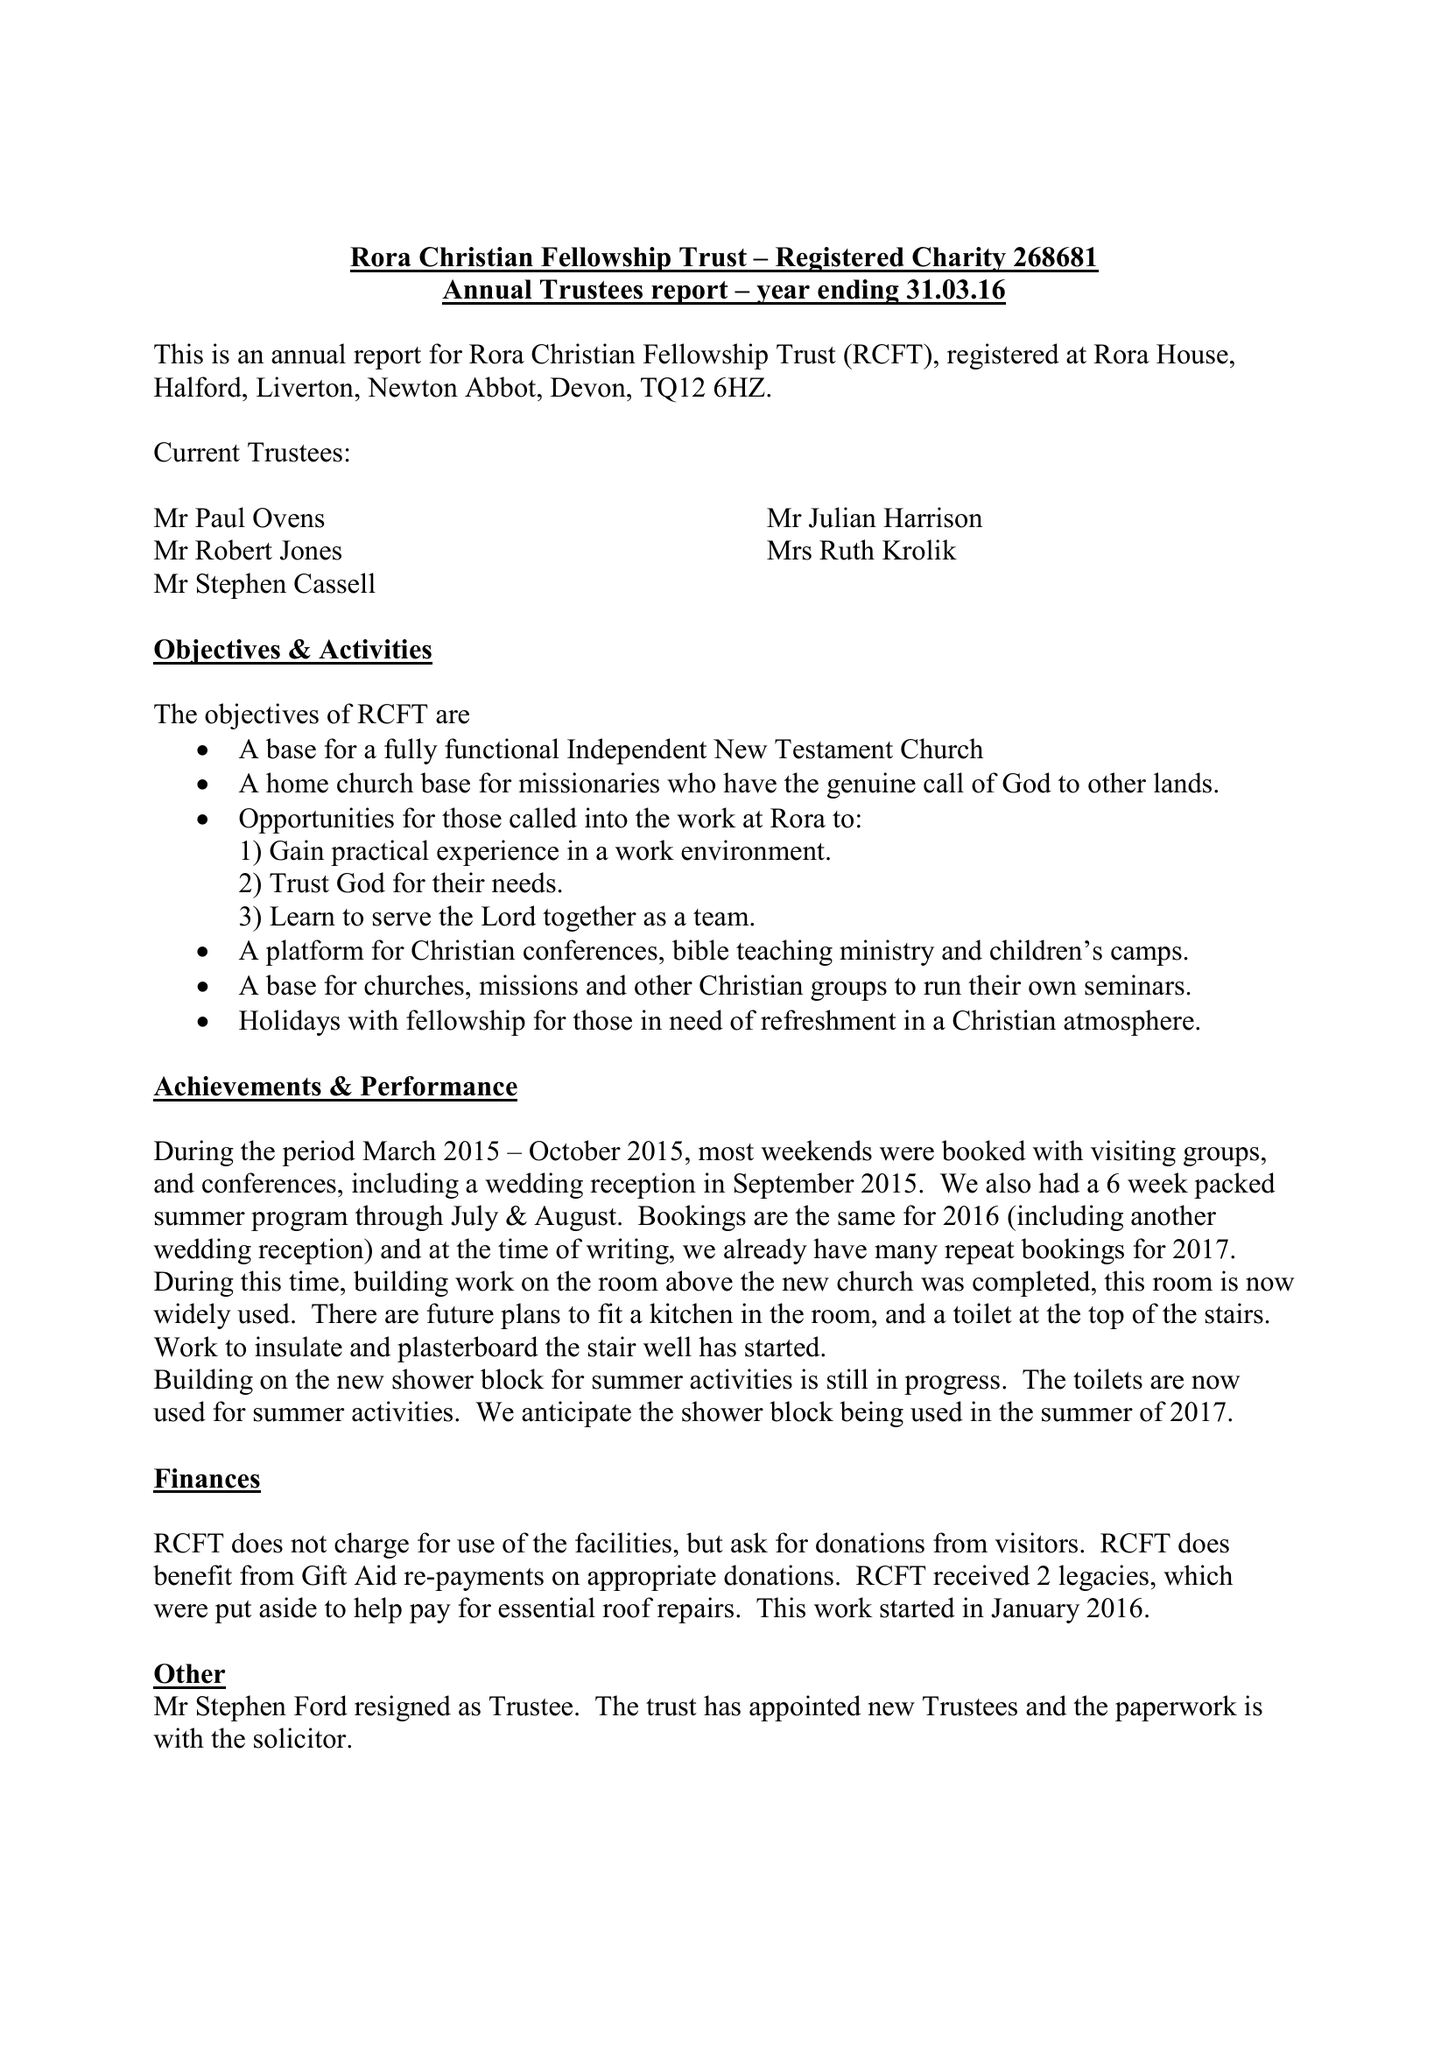What is the value for the address__street_line?
Answer the question using a single word or phrase. None 